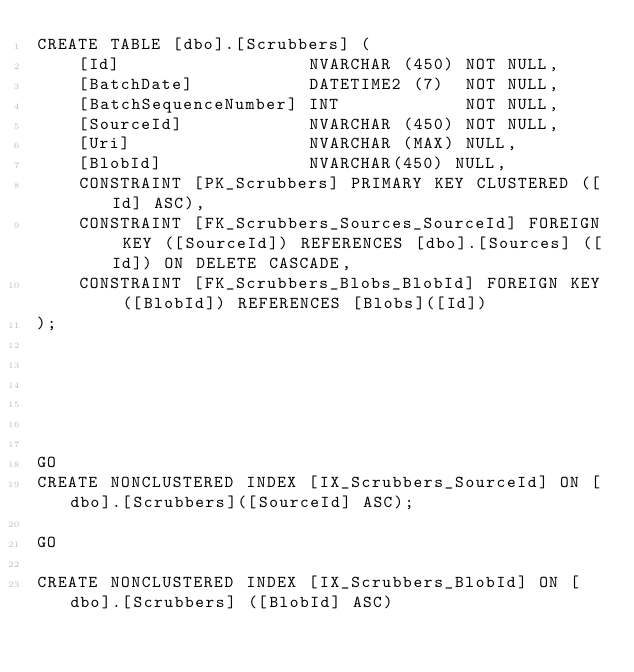Convert code to text. <code><loc_0><loc_0><loc_500><loc_500><_SQL_>CREATE TABLE [dbo].[Scrubbers] (
    [Id]                  NVARCHAR (450) NOT NULL,
    [BatchDate]           DATETIME2 (7)  NOT NULL,
    [BatchSequenceNumber] INT            NOT NULL,
    [SourceId]            NVARCHAR (450) NOT NULL,
    [Uri]                 NVARCHAR (MAX) NULL,
    [BlobId]              NVARCHAR(450) NULL, 
    CONSTRAINT [PK_Scrubbers] PRIMARY KEY CLUSTERED ([Id] ASC),
    CONSTRAINT [FK_Scrubbers_Sources_SourceId] FOREIGN KEY ([SourceId]) REFERENCES [dbo].[Sources] ([Id]) ON DELETE CASCADE,
    CONSTRAINT [FK_Scrubbers_Blobs_BlobId] FOREIGN KEY ([BlobId]) REFERENCES [Blobs]([Id])
);






GO
CREATE NONCLUSTERED INDEX [IX_Scrubbers_SourceId] ON [dbo].[Scrubbers]([SourceId] ASC);

GO

CREATE NONCLUSTERED INDEX [IX_Scrubbers_BlobId] ON [dbo].[Scrubbers] ([BlobId] ASC)
</code> 